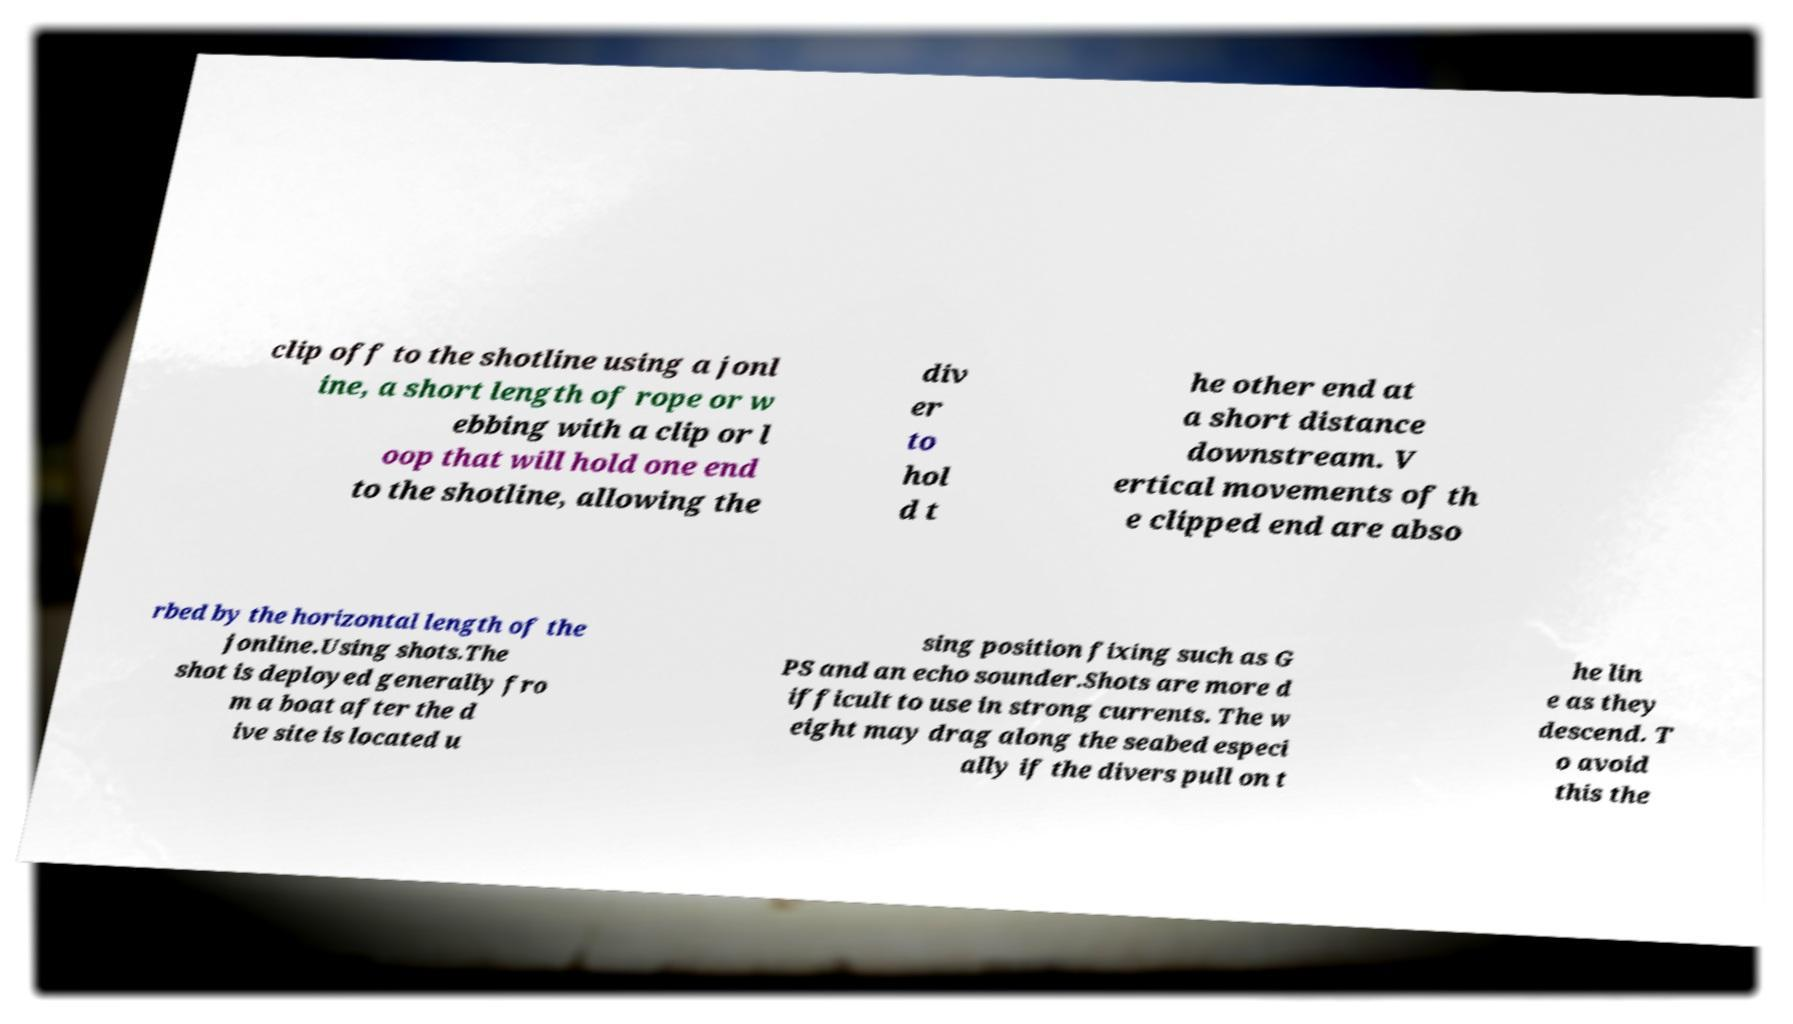Can you accurately transcribe the text from the provided image for me? clip off to the shotline using a jonl ine, a short length of rope or w ebbing with a clip or l oop that will hold one end to the shotline, allowing the div er to hol d t he other end at a short distance downstream. V ertical movements of th e clipped end are abso rbed by the horizontal length of the jonline.Using shots.The shot is deployed generally fro m a boat after the d ive site is located u sing position fixing such as G PS and an echo sounder.Shots are more d ifficult to use in strong currents. The w eight may drag along the seabed especi ally if the divers pull on t he lin e as they descend. T o avoid this the 